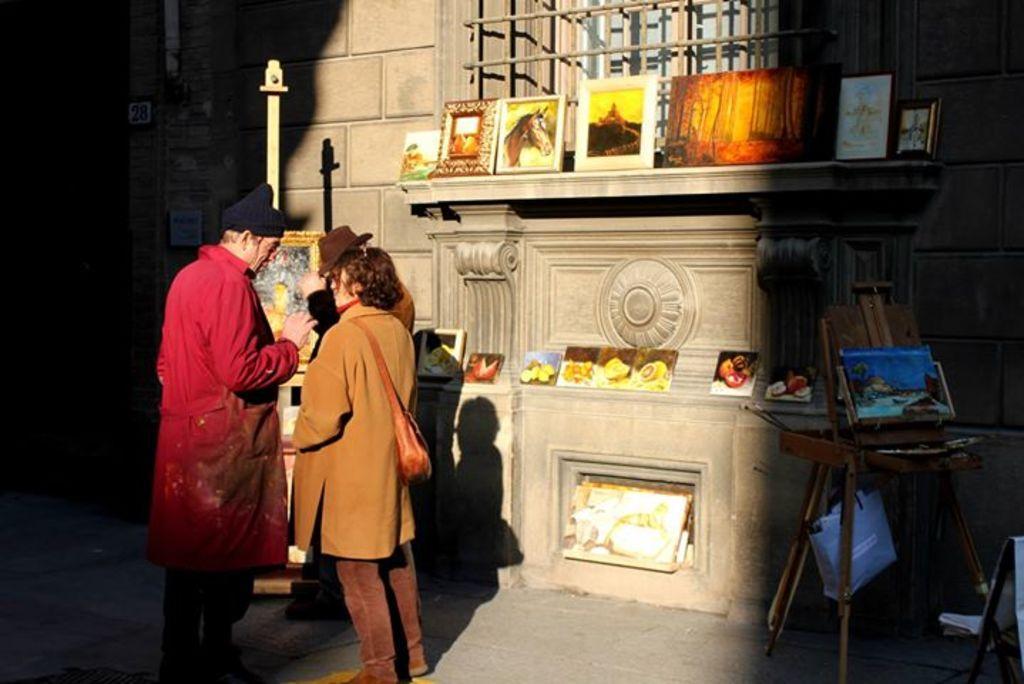Could you give a brief overview of what you see in this image? In this picture we can see two persons are standing on the road. This is wall and there are frames. 